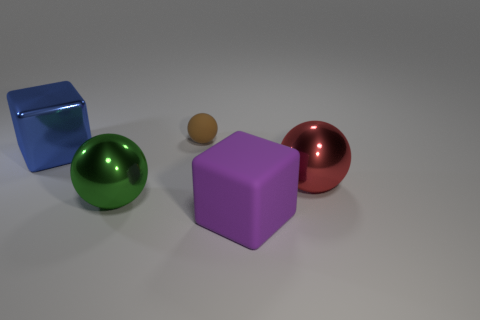How many objects are big blocks right of the blue cube or metal objects?
Your answer should be very brief. 4. Is the material of the cube to the left of the large matte object the same as the small sphere?
Give a very brief answer. No. Is the green metallic object the same shape as the red metal thing?
Offer a very short reply. Yes. How many red metal spheres are in front of the block in front of the green metal object?
Ensure brevity in your answer.  0. There is a tiny brown object that is the same shape as the big green object; what is it made of?
Give a very brief answer. Rubber. Is the color of the sphere behind the blue shiny cube the same as the big matte cube?
Offer a terse response. No. Does the big purple block have the same material as the big object that is to the right of the large purple rubber block?
Provide a short and direct response. No. There is a big shiny object that is in front of the big red sphere; what shape is it?
Provide a short and direct response. Sphere. How many other things are the same material as the large purple cube?
Provide a short and direct response. 1. The green thing has what size?
Your response must be concise. Large. 